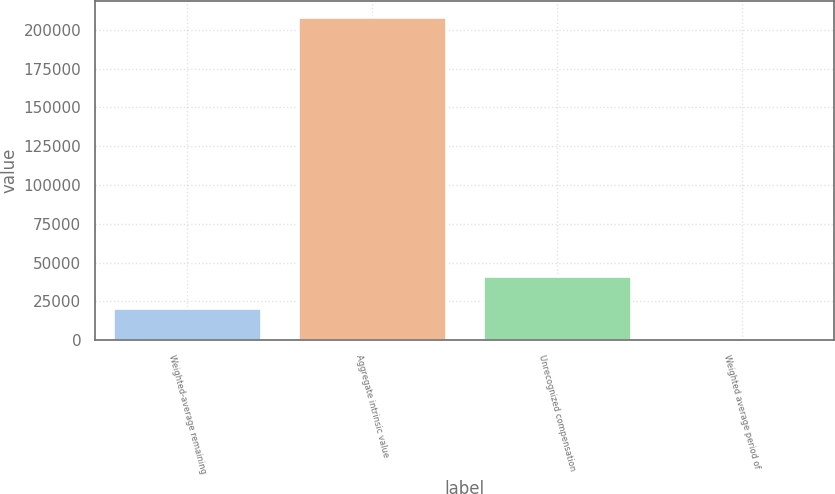Convert chart. <chart><loc_0><loc_0><loc_500><loc_500><bar_chart><fcel>Weighted-average remaining<fcel>Aggregate intrinsic value<fcel>Unrecognized compensation<fcel>Weighted average period of<nl><fcel>20816.1<fcel>208152<fcel>41631.2<fcel>0.96<nl></chart> 